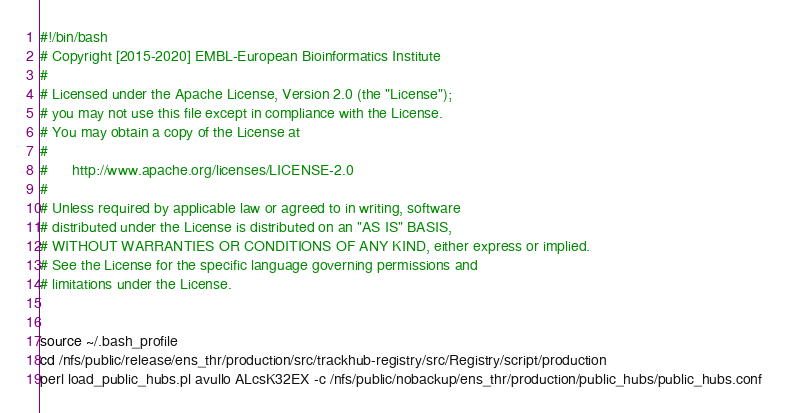Convert code to text. <code><loc_0><loc_0><loc_500><loc_500><_Bash_>#!/bin/bash
# Copyright [2015-2020] EMBL-European Bioinformatics Institute
# 
# Licensed under the Apache License, Version 2.0 (the "License");
# you may not use this file except in compliance with the License.
# You may obtain a copy of the License at
# 
#      http://www.apache.org/licenses/LICENSE-2.0
# 
# Unless required by applicable law or agreed to in writing, software
# distributed under the License is distributed on an "AS IS" BASIS,
# WITHOUT WARRANTIES OR CONDITIONS OF ANY KIND, either express or implied.
# See the License for the specific language governing permissions and
# limitations under the License.


source ~/.bash_profile
cd /nfs/public/release/ens_thr/production/src/trackhub-registry/src/Registry/script/production
perl load_public_hubs.pl avullo ALcsK32EX -c /nfs/public/nobackup/ens_thr/production/public_hubs/public_hubs.conf
</code> 